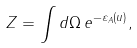Convert formula to latex. <formula><loc_0><loc_0><loc_500><loc_500>Z = \int d \Omega \, e ^ { - \varepsilon _ { A } ( { u } ) } ,</formula> 